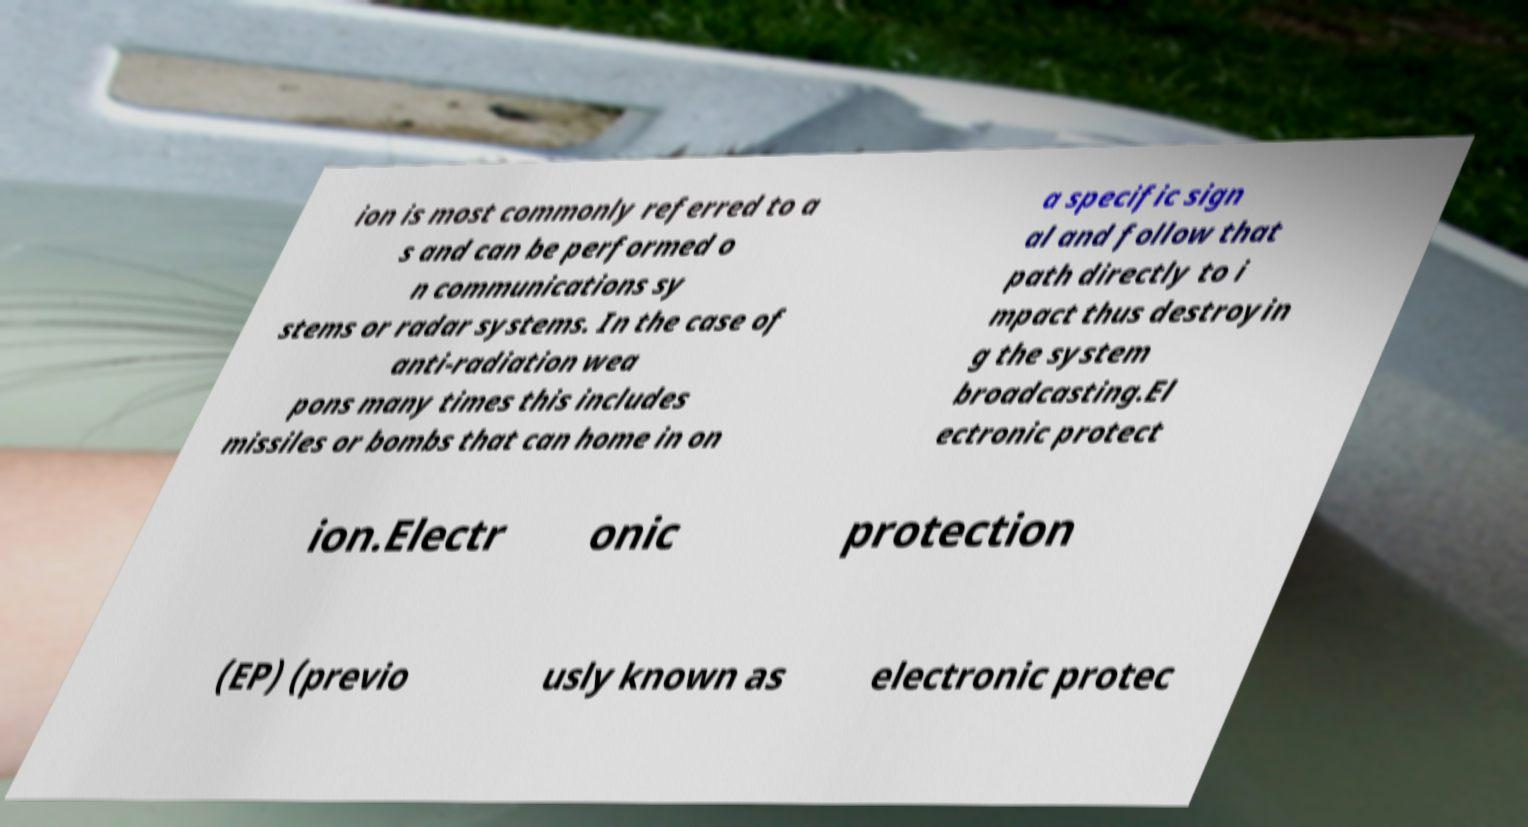Could you extract and type out the text from this image? ion is most commonly referred to a s and can be performed o n communications sy stems or radar systems. In the case of anti-radiation wea pons many times this includes missiles or bombs that can home in on a specific sign al and follow that path directly to i mpact thus destroyin g the system broadcasting.El ectronic protect ion.Electr onic protection (EP) (previo usly known as electronic protec 